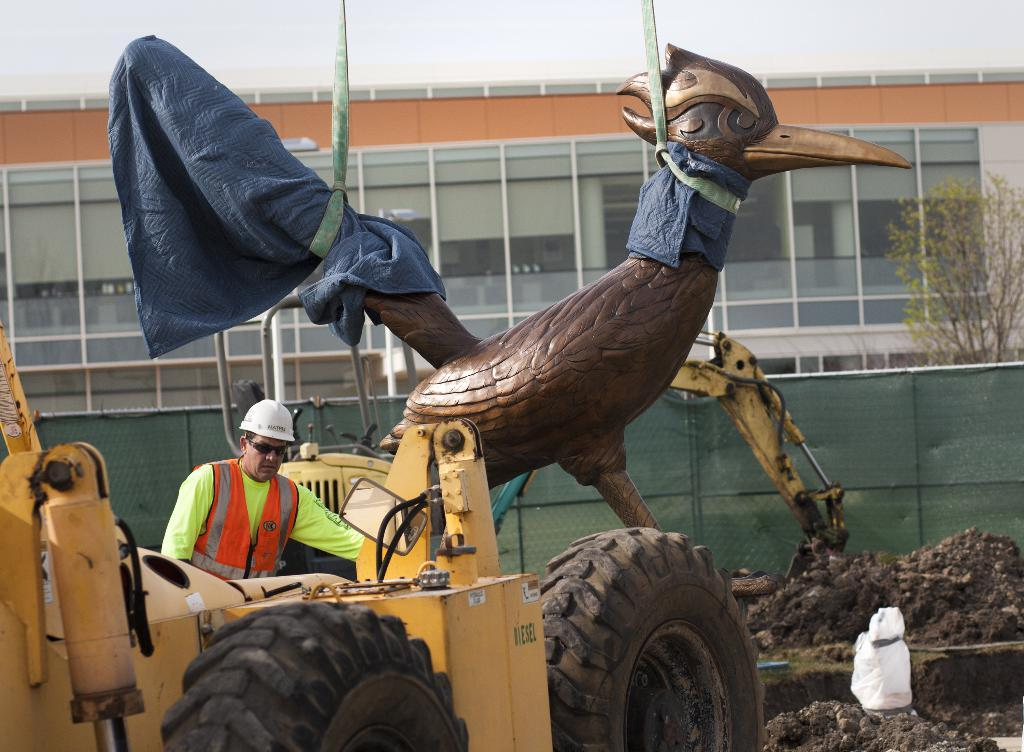What is the person in the image doing? There is a person operating a vehicle in the image. What can be seen in the image besides the vehicle and the person? There is a sculpture with ropes, fencing, trees, and buildings visible in the image. How does the sponge help the person operate the vehicle in the image? There is no sponge present in the image, so it cannot help the person operate the vehicle. 